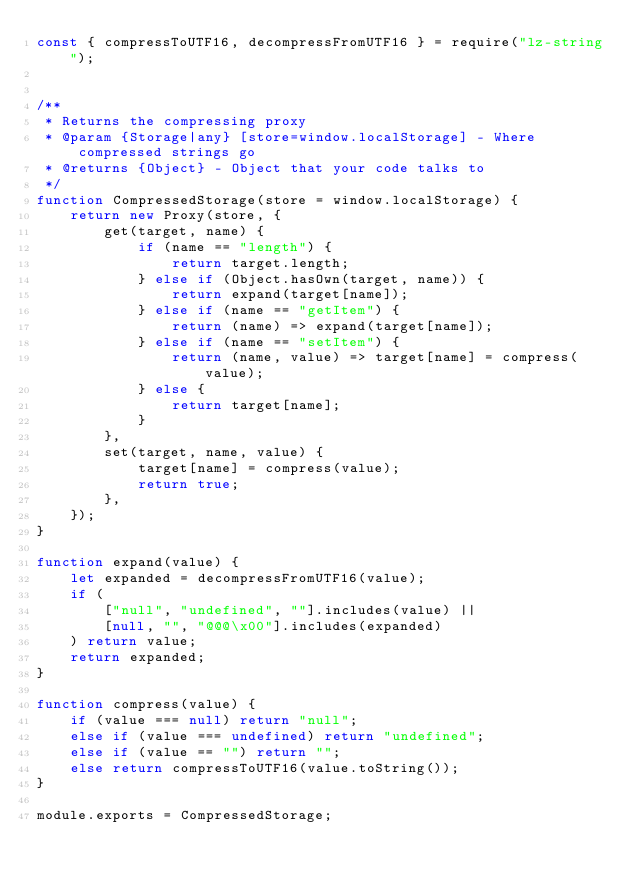<code> <loc_0><loc_0><loc_500><loc_500><_JavaScript_>const { compressToUTF16, decompressFromUTF16 } = require("lz-string");


/**
 * Returns the compressing proxy
 * @param {Storage|any} [store=window.localStorage] - Where compressed strings go
 * @returns {Object} - Object that your code talks to
 */
function CompressedStorage(store = window.localStorage) {
    return new Proxy(store, {
        get(target, name) {
            if (name == "length") {
                return target.length;
            } else if (Object.hasOwn(target, name)) {
                return expand(target[name]);
            } else if (name == "getItem") {
                return (name) => expand(target[name]);
            } else if (name == "setItem") {
                return (name, value) => target[name] = compress(value);
            } else {
                return target[name];
            }
        },
        set(target, name, value) {
            target[name] = compress(value);
            return true;
        },
    });
}

function expand(value) {
    let expanded = decompressFromUTF16(value);
    if (
        ["null", "undefined", ""].includes(value) ||
        [null, "", "@@@\x00"].includes(expanded)
    ) return value;
    return expanded;
}

function compress(value) {
    if (value === null) return "null";
    else if (value === undefined) return "undefined";
    else if (value == "") return "";
    else return compressToUTF16(value.toString());
}

module.exports = CompressedStorage;
</code> 